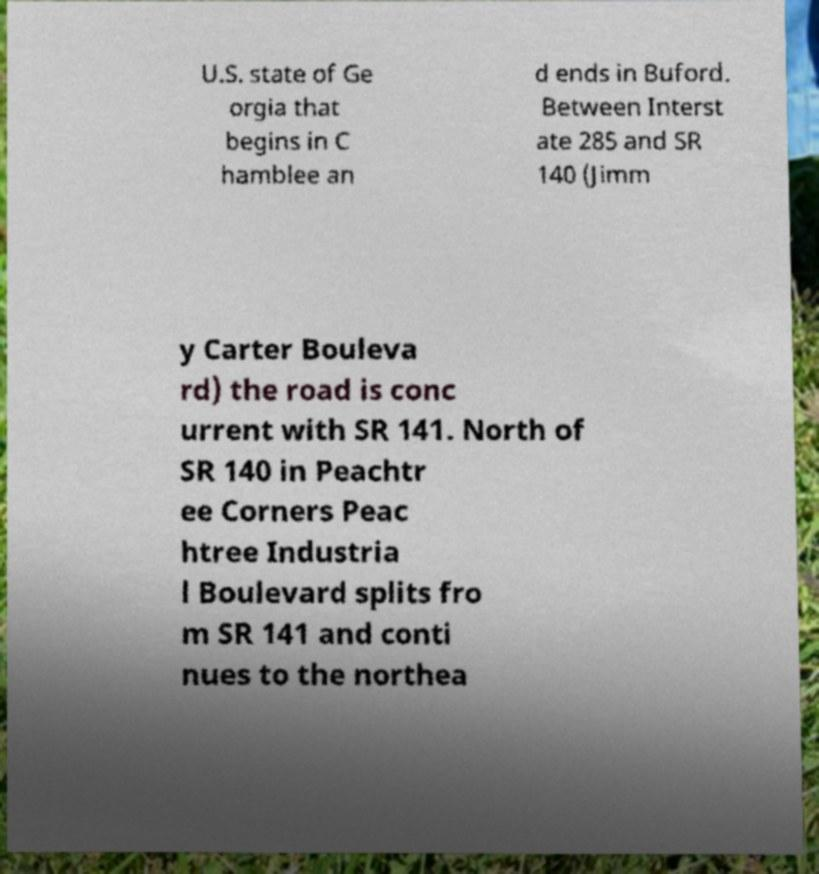Could you assist in decoding the text presented in this image and type it out clearly? U.S. state of Ge orgia that begins in C hamblee an d ends in Buford. Between Interst ate 285 and SR 140 (Jimm y Carter Bouleva rd) the road is conc urrent with SR 141. North of SR 140 in Peachtr ee Corners Peac htree Industria l Boulevard splits fro m SR 141 and conti nues to the northea 